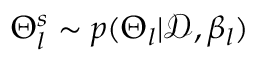Convert formula to latex. <formula><loc_0><loc_0><loc_500><loc_500>\Theta _ { l } ^ { s } \sim p ( \Theta _ { l } | \mathcal { D } , \beta _ { l } )</formula> 